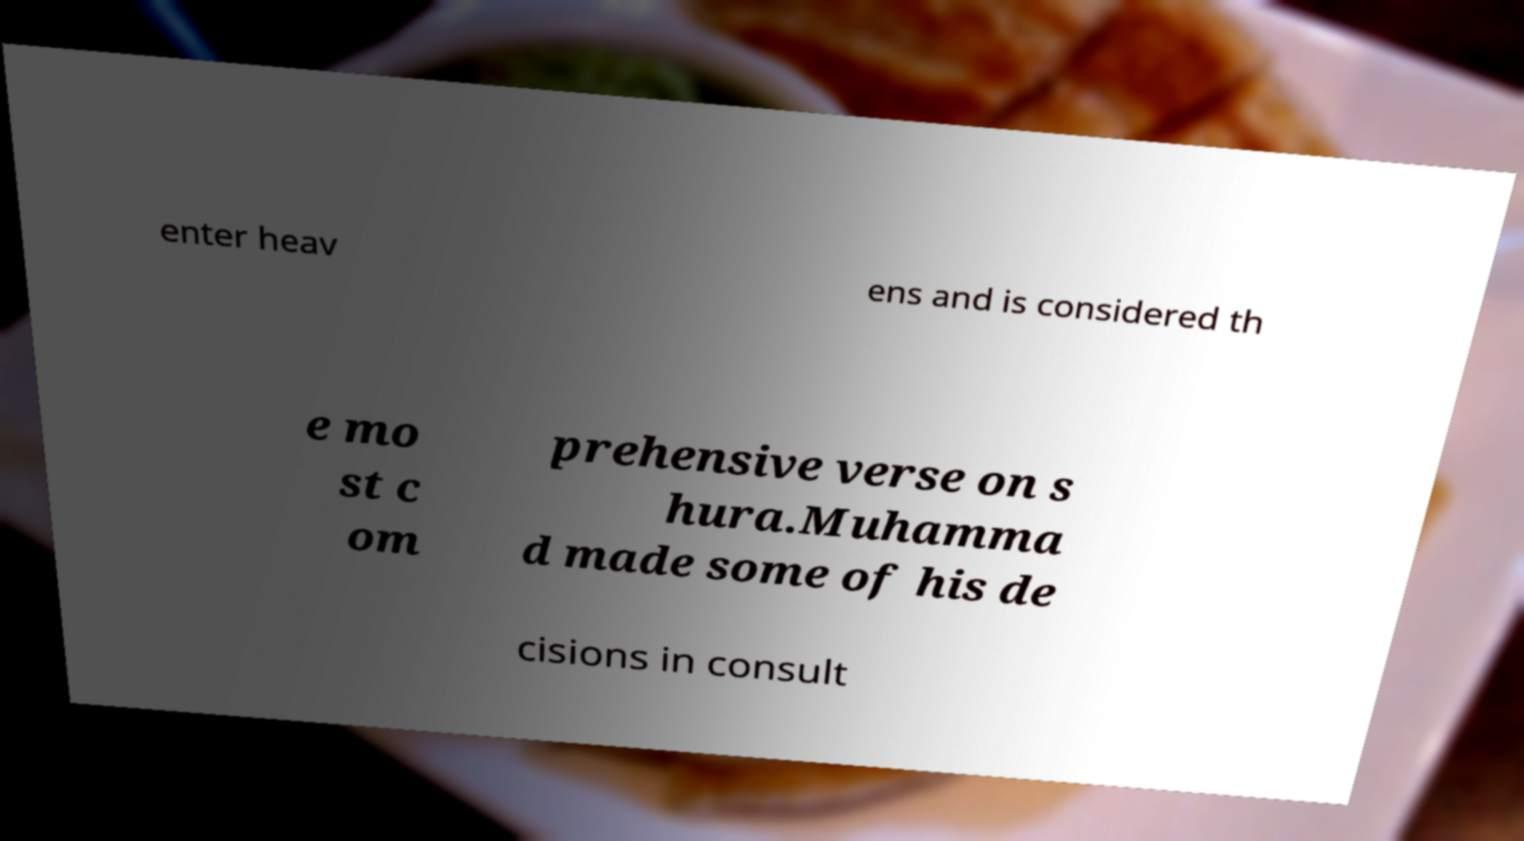There's text embedded in this image that I need extracted. Can you transcribe it verbatim? enter heav ens and is considered th e mo st c om prehensive verse on s hura.Muhamma d made some of his de cisions in consult 